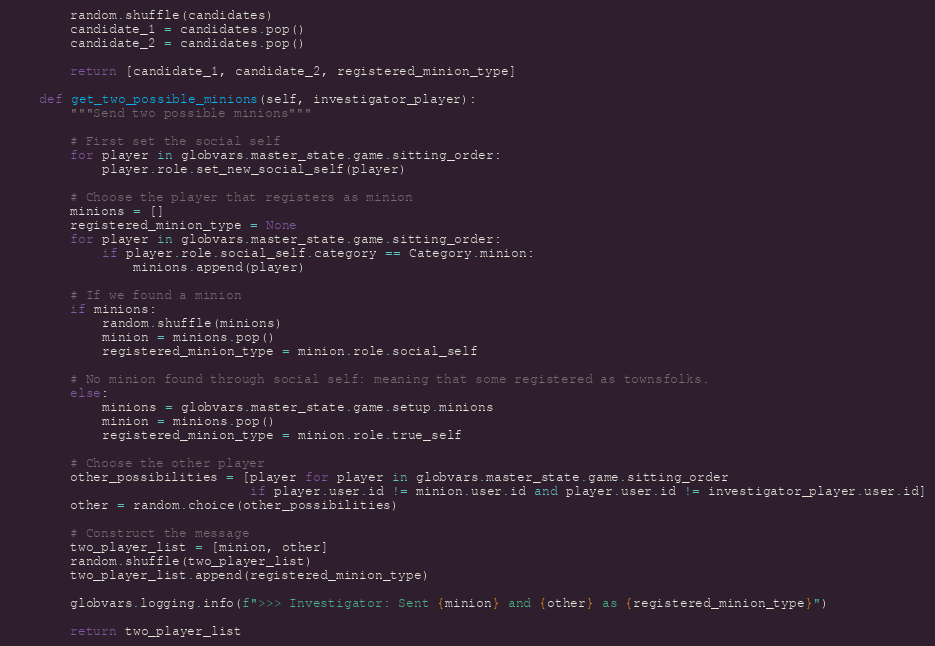<code> <loc_0><loc_0><loc_500><loc_500><_Python_>        random.shuffle(candidates)
        candidate_1 = candidates.pop()
        candidate_2 = candidates.pop()

        return [candidate_1, candidate_2, registered_minion_type]

    def get_two_possible_minions(self, investigator_player):
        """Send two possible minions"""

        # First set the social self
        for player in globvars.master_state.game.sitting_order:
            player.role.set_new_social_self(player)

        # Choose the player that registers as minion
        minions = []
        registered_minion_type = None
        for player in globvars.master_state.game.sitting_order:
            if player.role.social_self.category == Category.minion:
                minions.append(player)

        # If we found a minion
        if minions:
            random.shuffle(minions)
            minion = minions.pop()
            registered_minion_type = minion.role.social_self

        # No minion found through social self: meaning that some registered as townsfolks.
        else:
            minions = globvars.master_state.game.setup.minions
            minion = minions.pop()
            registered_minion_type = minion.role.true_self

        # Choose the other player
        other_possibilities = [player for player in globvars.master_state.game.sitting_order 
                               if player.user.id != minion.user.id and player.user.id != investigator_player.user.id]
        other = random.choice(other_possibilities)
        
        # Construct the message
        two_player_list = [minion, other]
        random.shuffle(two_player_list)
        two_player_list.append(registered_minion_type)

        globvars.logging.info(f">>> Investigator: Sent {minion} and {other} as {registered_minion_type}")

        return two_player_list
</code> 